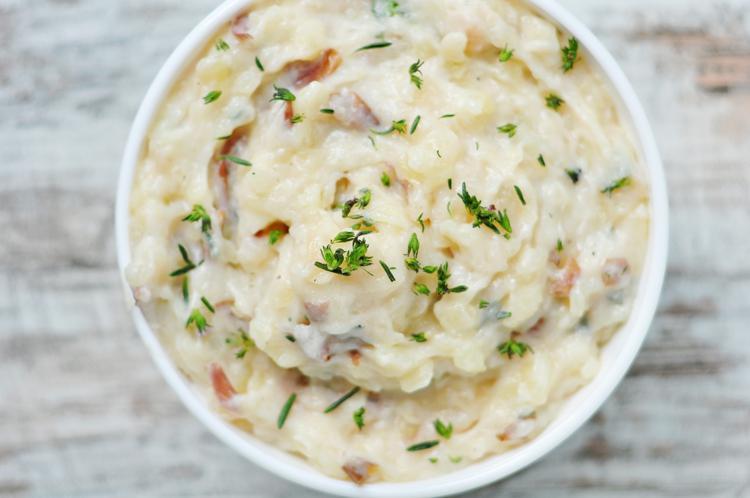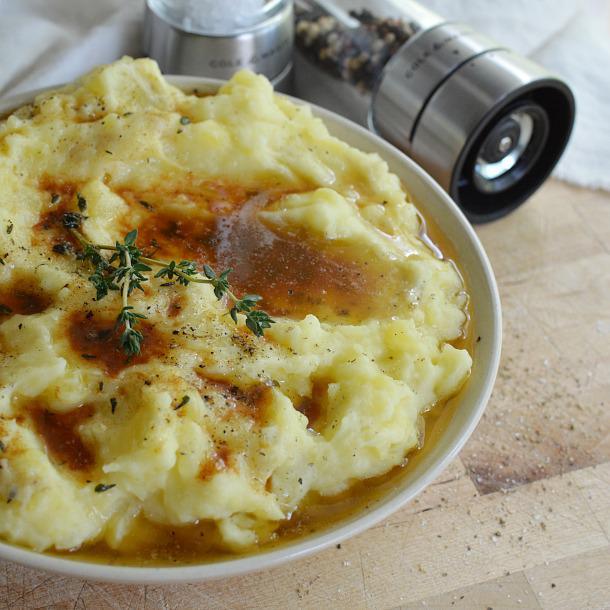The first image is the image on the left, the second image is the image on the right. Given the left and right images, does the statement "There is a cylindrical, silver pepper grinder behind a bowl of mashed potatoes in one of the images." hold true? Answer yes or no. Yes. The first image is the image on the left, the second image is the image on the right. Considering the images on both sides, is "A cylindrical spice grinder is laying alongside a bowl of mashed potatoes doused with brownish liquid." valid? Answer yes or no. Yes. 